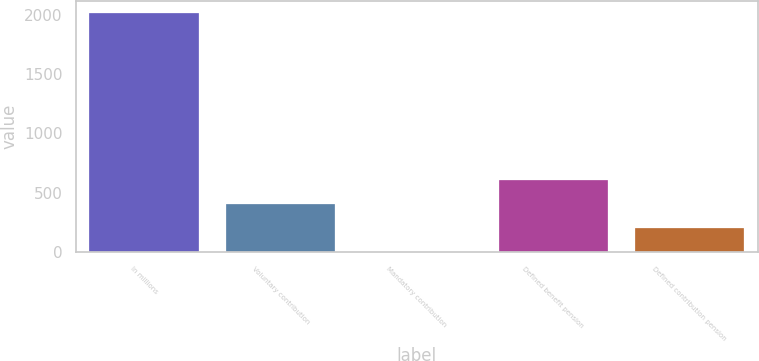Convert chart. <chart><loc_0><loc_0><loc_500><loc_500><bar_chart><fcel>In millions<fcel>Voluntary contribution<fcel>Mandatory contribution<fcel>Defined benefit pension<fcel>Defined contribution pension<nl><fcel>2016<fcel>404<fcel>1<fcel>605.5<fcel>202.5<nl></chart> 